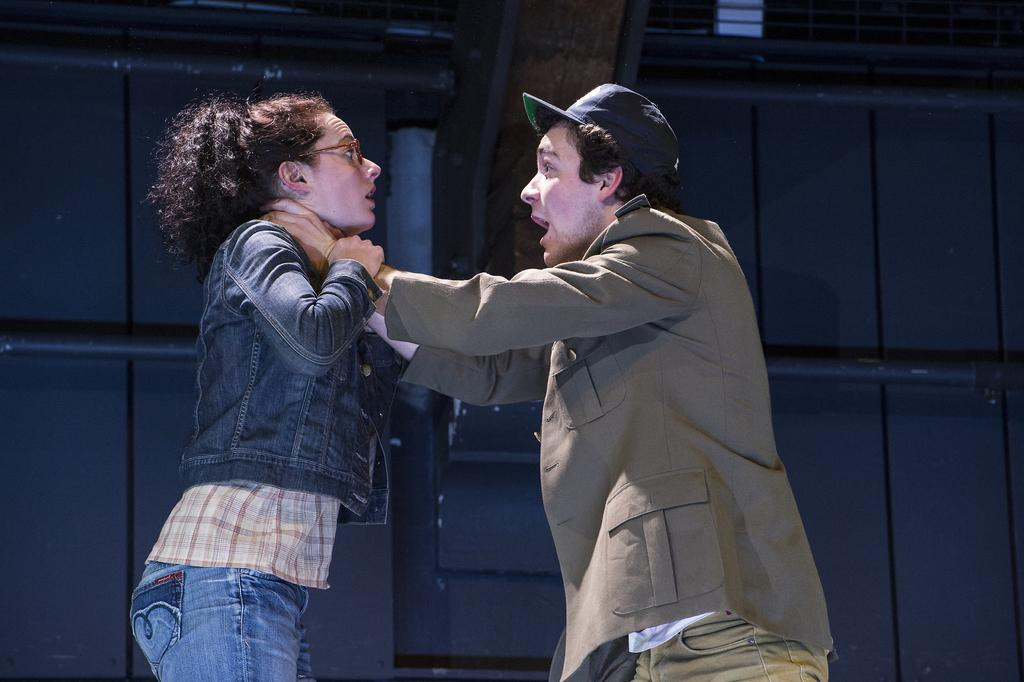How many people are in the image? There are two people in the center of the image. What can be seen in the background of the image? There is a building in the background of the image. What type of wrench is being used by one of the people in the image? There is no wrench present in the image; it only features two people and a building in the background. 